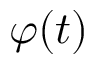<formula> <loc_0><loc_0><loc_500><loc_500>\varphi ( t )</formula> 